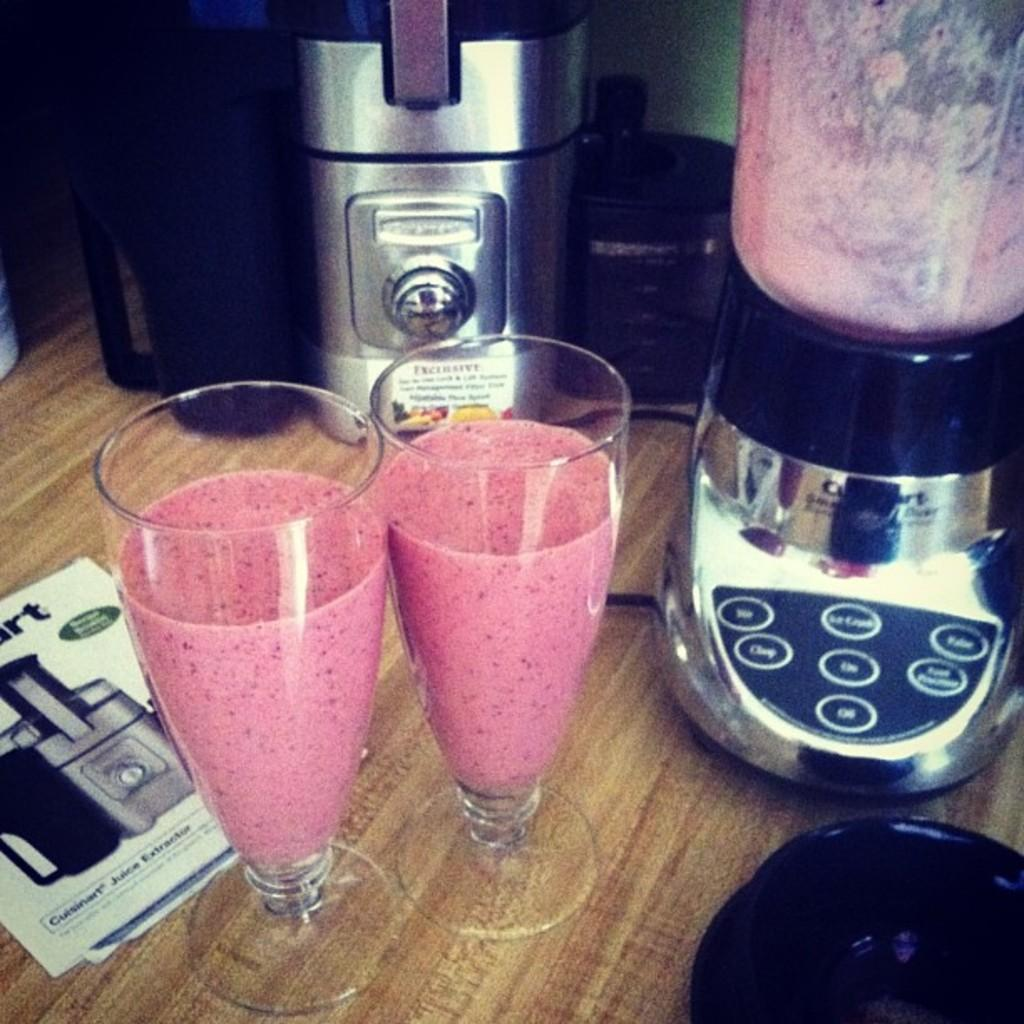<image>
Render a clear and concise summary of the photo. A Cuisinart instruction booklet sits on a counter next to 2 blended drinks. 